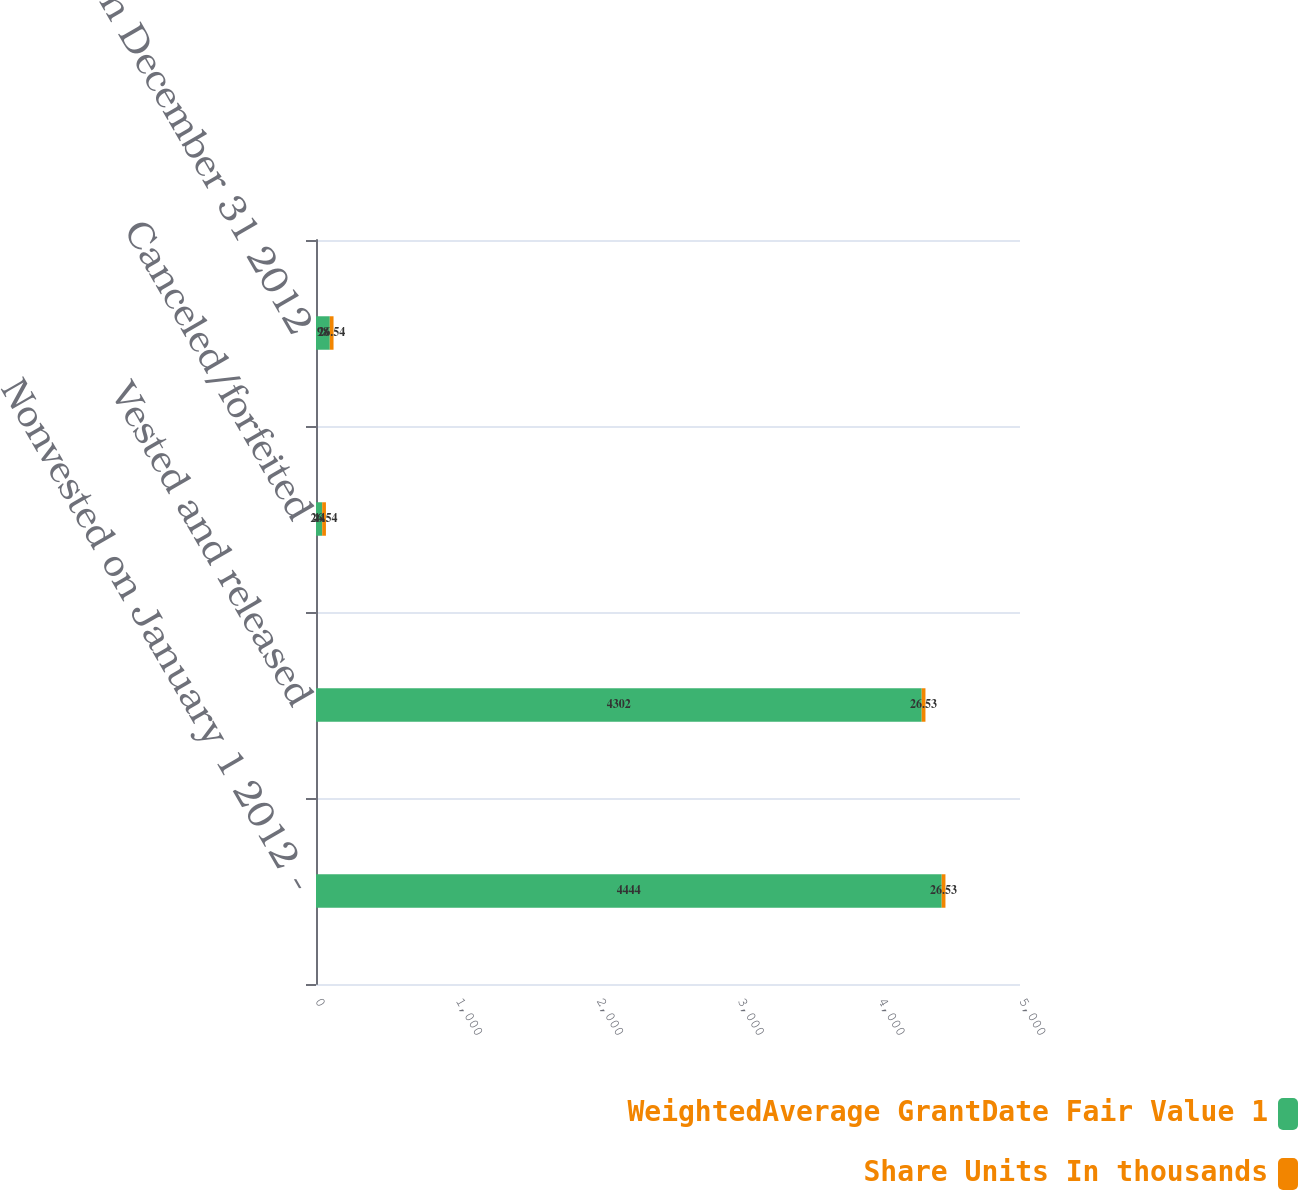<chart> <loc_0><loc_0><loc_500><loc_500><stacked_bar_chart><ecel><fcel>Nonvested on January 1 2012 -<fcel>Vested and released<fcel>Canceled/forfeited<fcel>Nonvested on December 31 2012<nl><fcel>WeightedAverage GrantDate Fair Value 1<fcel>4444<fcel>4302<fcel>44<fcel>98<nl><fcel>Share Units In thousands<fcel>26.53<fcel>26.53<fcel>26.54<fcel>26.54<nl></chart> 